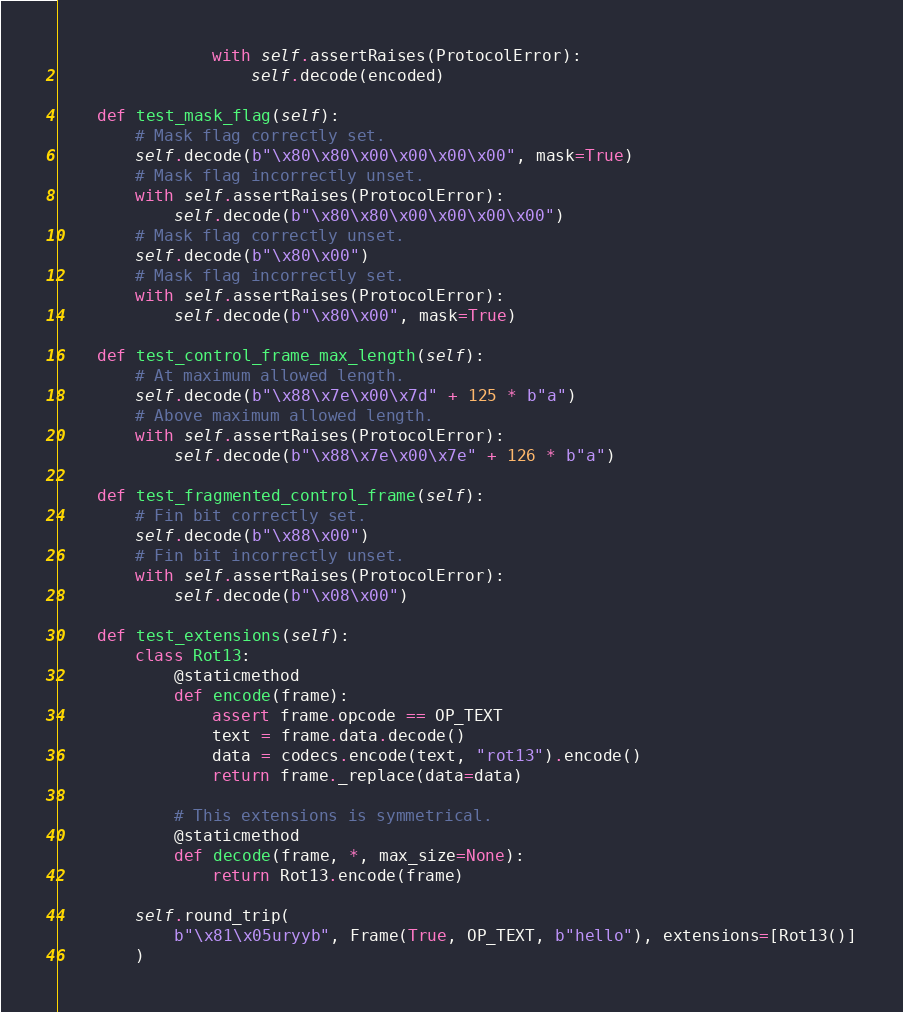<code> <loc_0><loc_0><loc_500><loc_500><_Python_>                with self.assertRaises(ProtocolError):
                    self.decode(encoded)

    def test_mask_flag(self):
        # Mask flag correctly set.
        self.decode(b"\x80\x80\x00\x00\x00\x00", mask=True)
        # Mask flag incorrectly unset.
        with self.assertRaises(ProtocolError):
            self.decode(b"\x80\x80\x00\x00\x00\x00")
        # Mask flag correctly unset.
        self.decode(b"\x80\x00")
        # Mask flag incorrectly set.
        with self.assertRaises(ProtocolError):
            self.decode(b"\x80\x00", mask=True)

    def test_control_frame_max_length(self):
        # At maximum allowed length.
        self.decode(b"\x88\x7e\x00\x7d" + 125 * b"a")
        # Above maximum allowed length.
        with self.assertRaises(ProtocolError):
            self.decode(b"\x88\x7e\x00\x7e" + 126 * b"a")

    def test_fragmented_control_frame(self):
        # Fin bit correctly set.
        self.decode(b"\x88\x00")
        # Fin bit incorrectly unset.
        with self.assertRaises(ProtocolError):
            self.decode(b"\x08\x00")

    def test_extensions(self):
        class Rot13:
            @staticmethod
            def encode(frame):
                assert frame.opcode == OP_TEXT
                text = frame.data.decode()
                data = codecs.encode(text, "rot13").encode()
                return frame._replace(data=data)

            # This extensions is symmetrical.
            @staticmethod
            def decode(frame, *, max_size=None):
                return Rot13.encode(frame)

        self.round_trip(
            b"\x81\x05uryyb", Frame(True, OP_TEXT, b"hello"), extensions=[Rot13()]
        )
</code> 